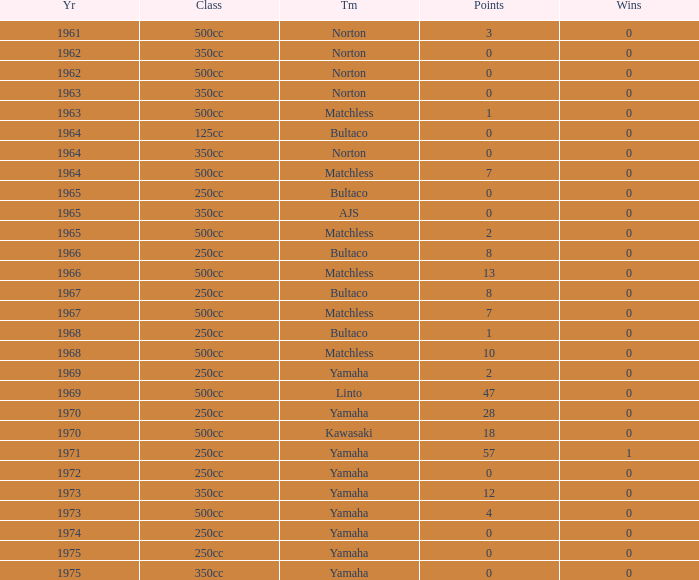Which class corresponds to more than 2 points, wins greater than 0, and a year earlier than 1973? 250cc. 